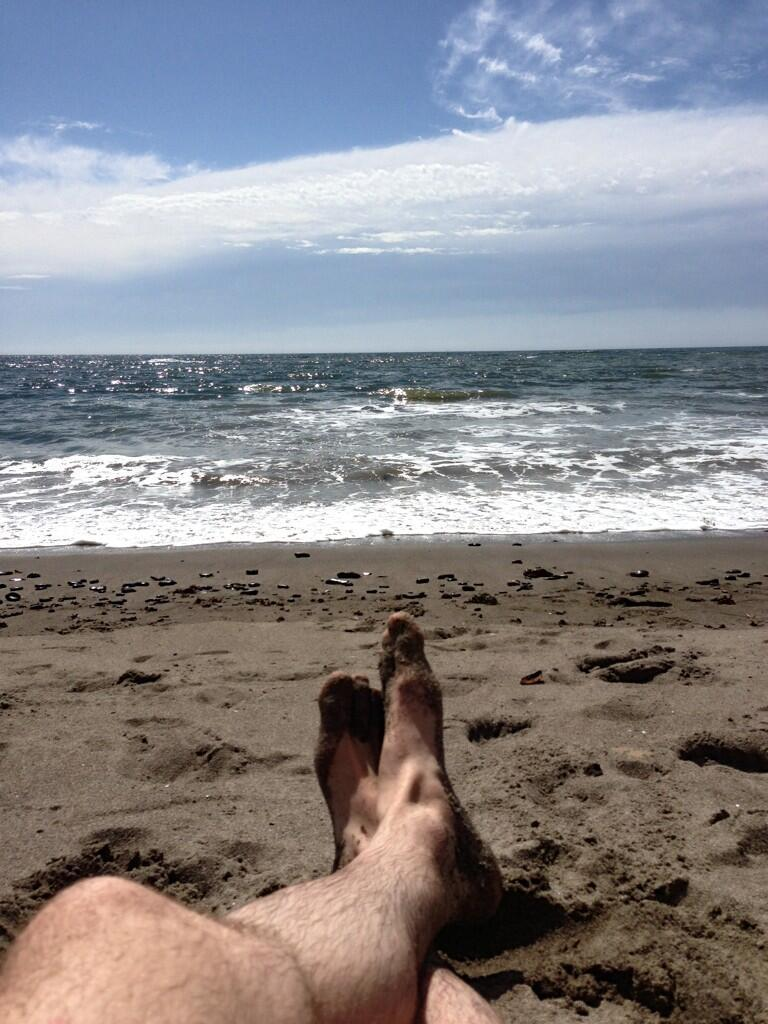What part of a person can be seen in the image? There are legs of a person visible in the image. What surface are the legs on? The legs are on the sand. What can be seen in the distance in the image? There is water visible in the background of the image. What else is visible in the background of the image? The sky is visible in the background of the image, and clouds are present in the sky. What type of cabbage is growing on the sand in the image? There is no cabbage present in the image; it features the legs of a person on the sand. Can you see any mice running on the cable in the image? There is no cable or mice present in the image. 